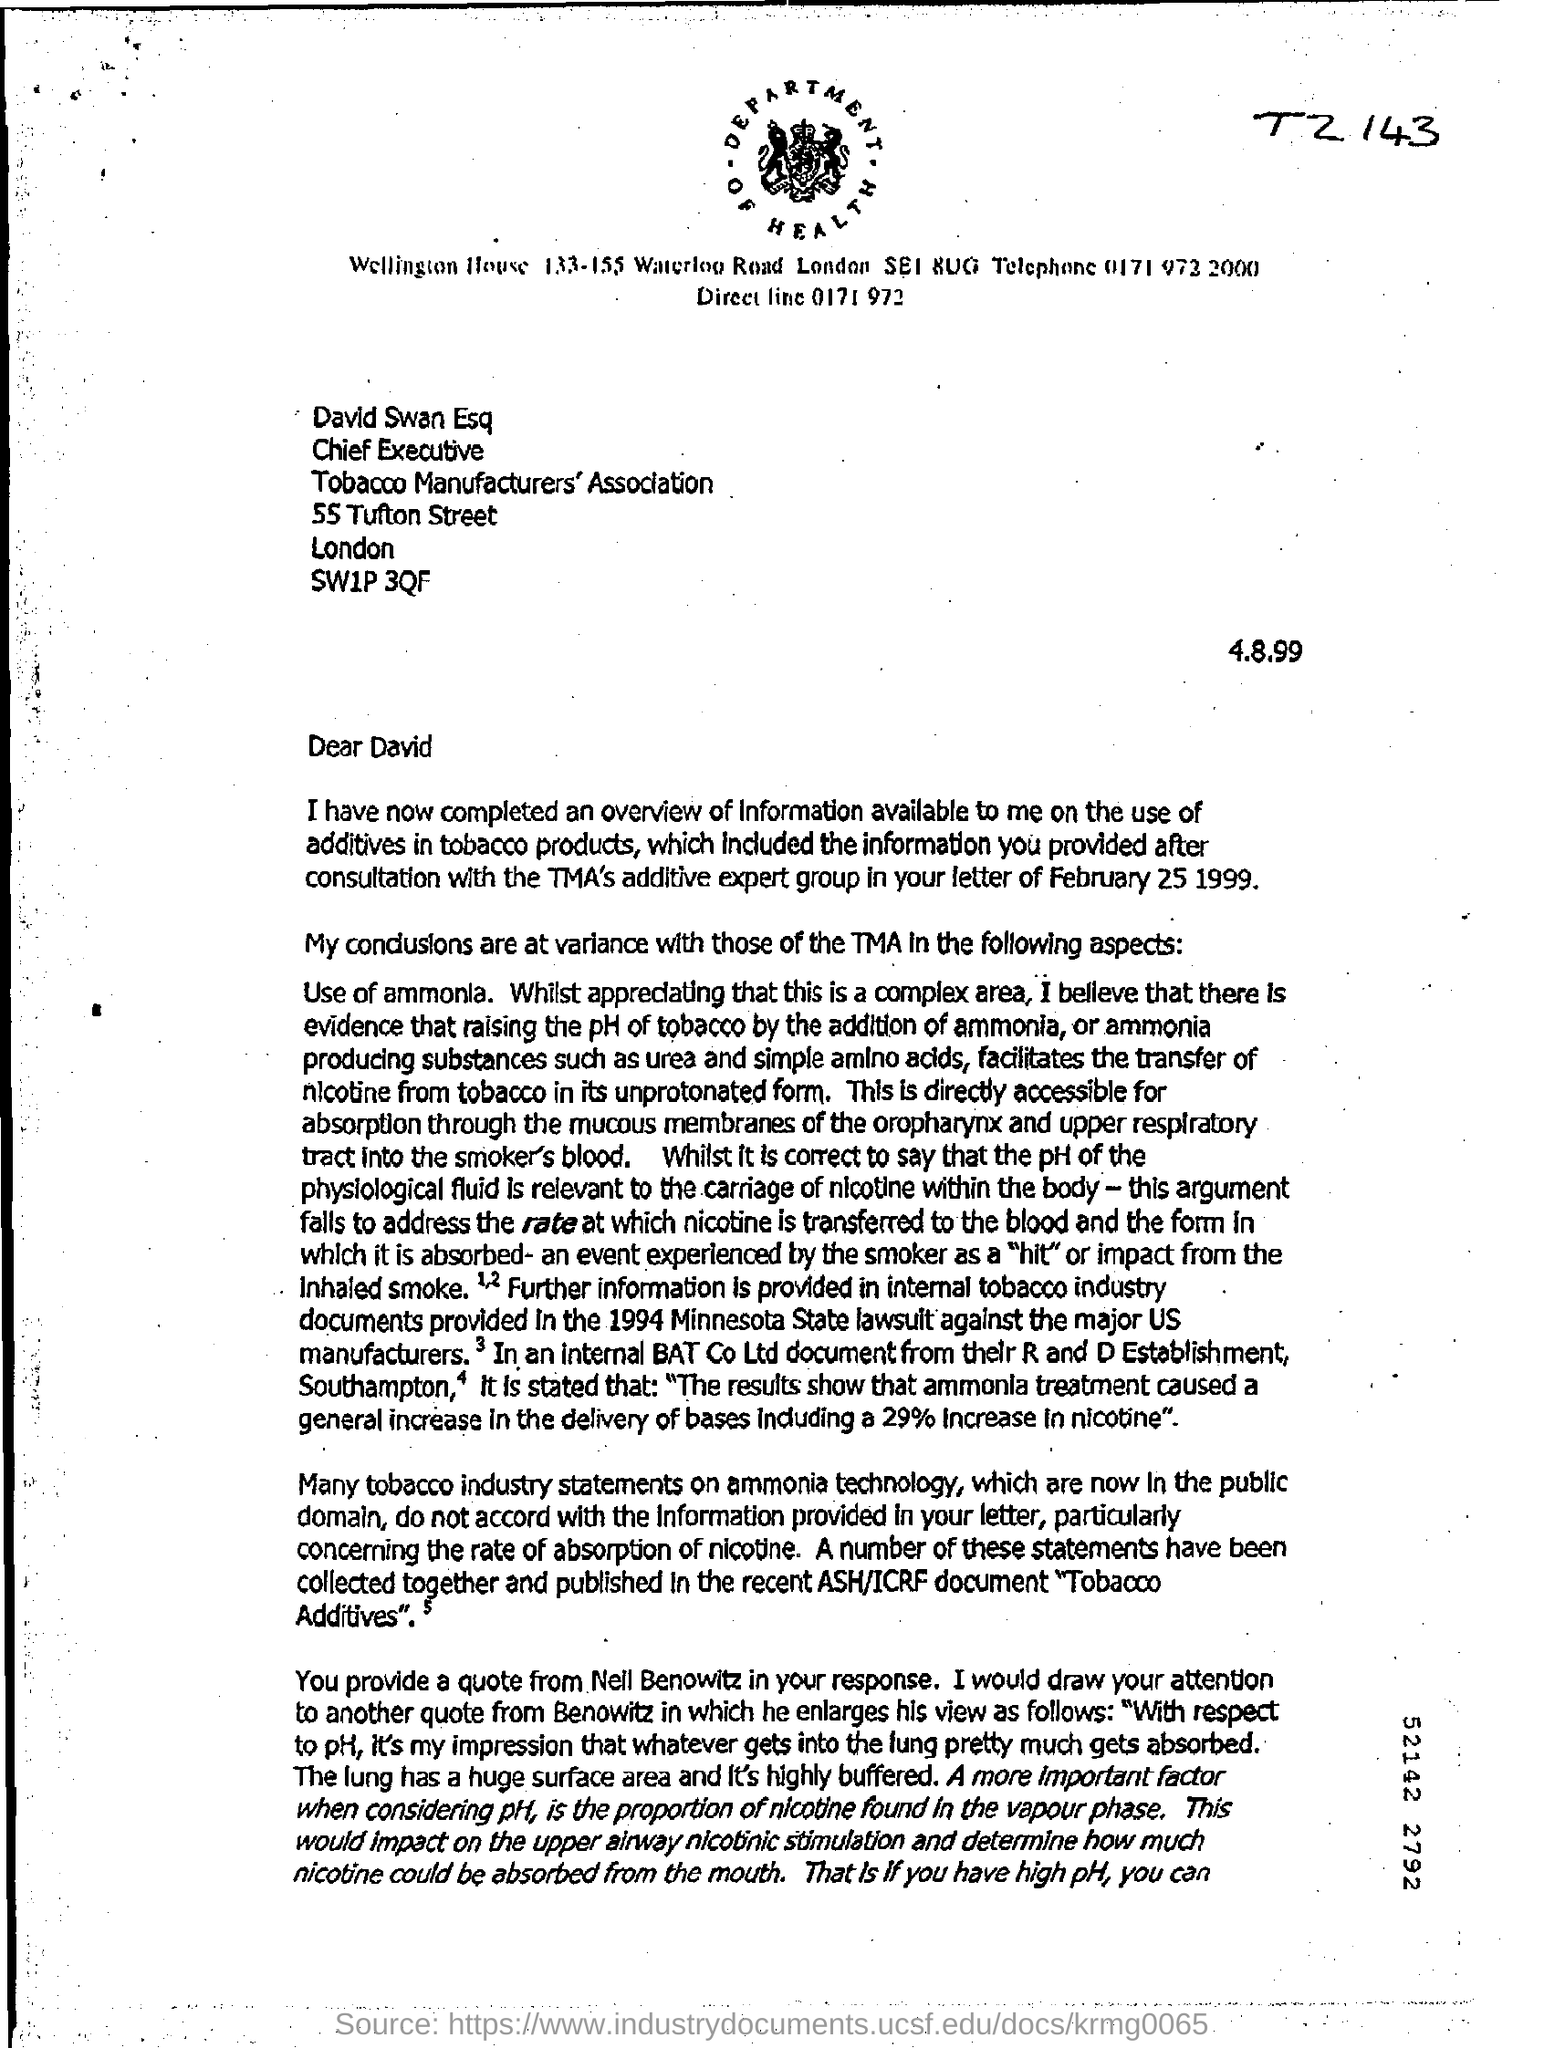List a handful of essential elements in this visual. The Tobacco Manufacturers' Association's street address is located at 55 Tufton Street. David Swan, Esquire, holds the position of Chief Executive. 